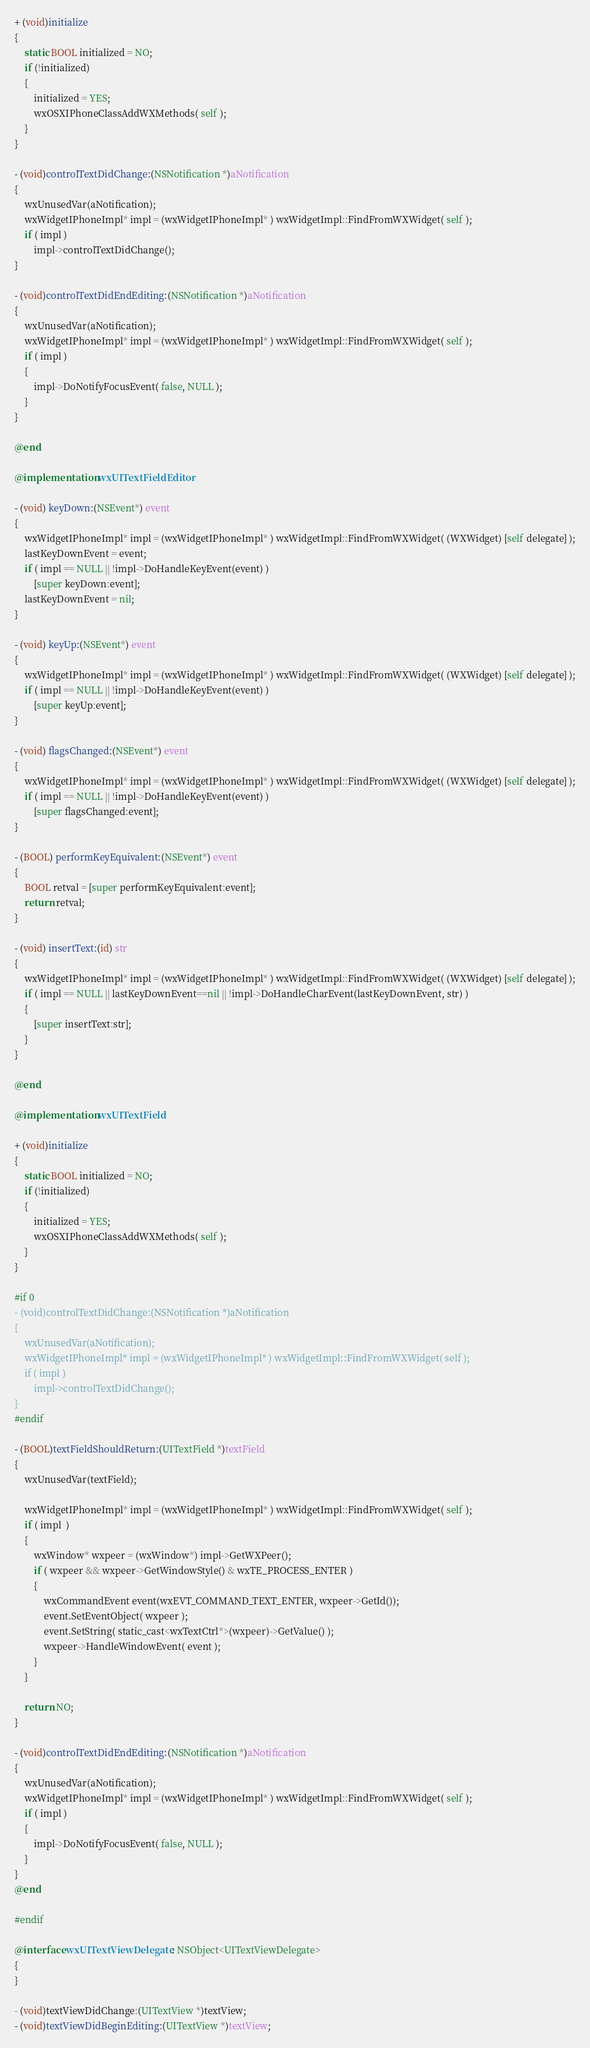Convert code to text. <code><loc_0><loc_0><loc_500><loc_500><_ObjectiveC_>
+ (void)initialize
{
    static BOOL initialized = NO;
    if (!initialized)
    {
        initialized = YES;
        wxOSXIPhoneClassAddWXMethods( self );
    }
}

- (void)controlTextDidChange:(NSNotification *)aNotification
{
    wxUnusedVar(aNotification);
    wxWidgetIPhoneImpl* impl = (wxWidgetIPhoneImpl* ) wxWidgetImpl::FindFromWXWidget( self );
    if ( impl )
        impl->controlTextDidChange();
}

- (void)controlTextDidEndEditing:(NSNotification *)aNotification
{
    wxUnusedVar(aNotification);
    wxWidgetIPhoneImpl* impl = (wxWidgetIPhoneImpl* ) wxWidgetImpl::FindFromWXWidget( self );
    if ( impl )
    {
        impl->DoNotifyFocusEvent( false, NULL );
    }
}

@end

@implementation wxUITextFieldEditor

- (void) keyDown:(NSEvent*) event
{
    wxWidgetIPhoneImpl* impl = (wxWidgetIPhoneImpl* ) wxWidgetImpl::FindFromWXWidget( (WXWidget) [self delegate] );
    lastKeyDownEvent = event;
    if ( impl == NULL || !impl->DoHandleKeyEvent(event) )
        [super keyDown:event];
    lastKeyDownEvent = nil;
}

- (void) keyUp:(NSEvent*) event
{
    wxWidgetIPhoneImpl* impl = (wxWidgetIPhoneImpl* ) wxWidgetImpl::FindFromWXWidget( (WXWidget) [self delegate] );
    if ( impl == NULL || !impl->DoHandleKeyEvent(event) )
        [super keyUp:event];
}

- (void) flagsChanged:(NSEvent*) event
{
    wxWidgetIPhoneImpl* impl = (wxWidgetIPhoneImpl* ) wxWidgetImpl::FindFromWXWidget( (WXWidget) [self delegate] );
    if ( impl == NULL || !impl->DoHandleKeyEvent(event) )
        [super flagsChanged:event];
}

- (BOOL) performKeyEquivalent:(NSEvent*) event
{
    BOOL retval = [super performKeyEquivalent:event];
    return retval;
}

- (void) insertText:(id) str
{
    wxWidgetIPhoneImpl* impl = (wxWidgetIPhoneImpl* ) wxWidgetImpl::FindFromWXWidget( (WXWidget) [self delegate] );
    if ( impl == NULL || lastKeyDownEvent==nil || !impl->DoHandleCharEvent(lastKeyDownEvent, str) )
    {
        [super insertText:str];
    }
}

@end

@implementation wxUITextField

+ (void)initialize
{
    static BOOL initialized = NO;
    if (!initialized)
    {
        initialized = YES;
        wxOSXIPhoneClassAddWXMethods( self );
    }
}

#if 0
- (void)controlTextDidChange:(NSNotification *)aNotification
{
    wxUnusedVar(aNotification);
    wxWidgetIPhoneImpl* impl = (wxWidgetIPhoneImpl* ) wxWidgetImpl::FindFromWXWidget( self );
    if ( impl )
        impl->controlTextDidChange();
}
#endif

- (BOOL)textFieldShouldReturn:(UITextField *)textField
{
    wxUnusedVar(textField);
    
    wxWidgetIPhoneImpl* impl = (wxWidgetIPhoneImpl* ) wxWidgetImpl::FindFromWXWidget( self );
    if ( impl  )
    {
        wxWindow* wxpeer = (wxWindow*) impl->GetWXPeer();
        if ( wxpeer && wxpeer->GetWindowStyle() & wxTE_PROCESS_ENTER )
        {
            wxCommandEvent event(wxEVT_COMMAND_TEXT_ENTER, wxpeer->GetId());
            event.SetEventObject( wxpeer );
            event.SetString( static_cast<wxTextCtrl*>(wxpeer)->GetValue() );
            wxpeer->HandleWindowEvent( event );
        }
    }
    
    return NO;
}

- (void)controlTextDidEndEditing:(NSNotification *)aNotification
{
    wxUnusedVar(aNotification);
    wxWidgetIPhoneImpl* impl = (wxWidgetIPhoneImpl* ) wxWidgetImpl::FindFromWXWidget( self );
    if ( impl )
    {
        impl->DoNotifyFocusEvent( false, NULL );
    }
}
@end

#endif

@interface wxUITextViewDelegate : NSObject<UITextViewDelegate>
{
}

- (void)textViewDidChange:(UITextView *)textView;
- (void)textViewDidBeginEditing:(UITextView *)textView;</code> 